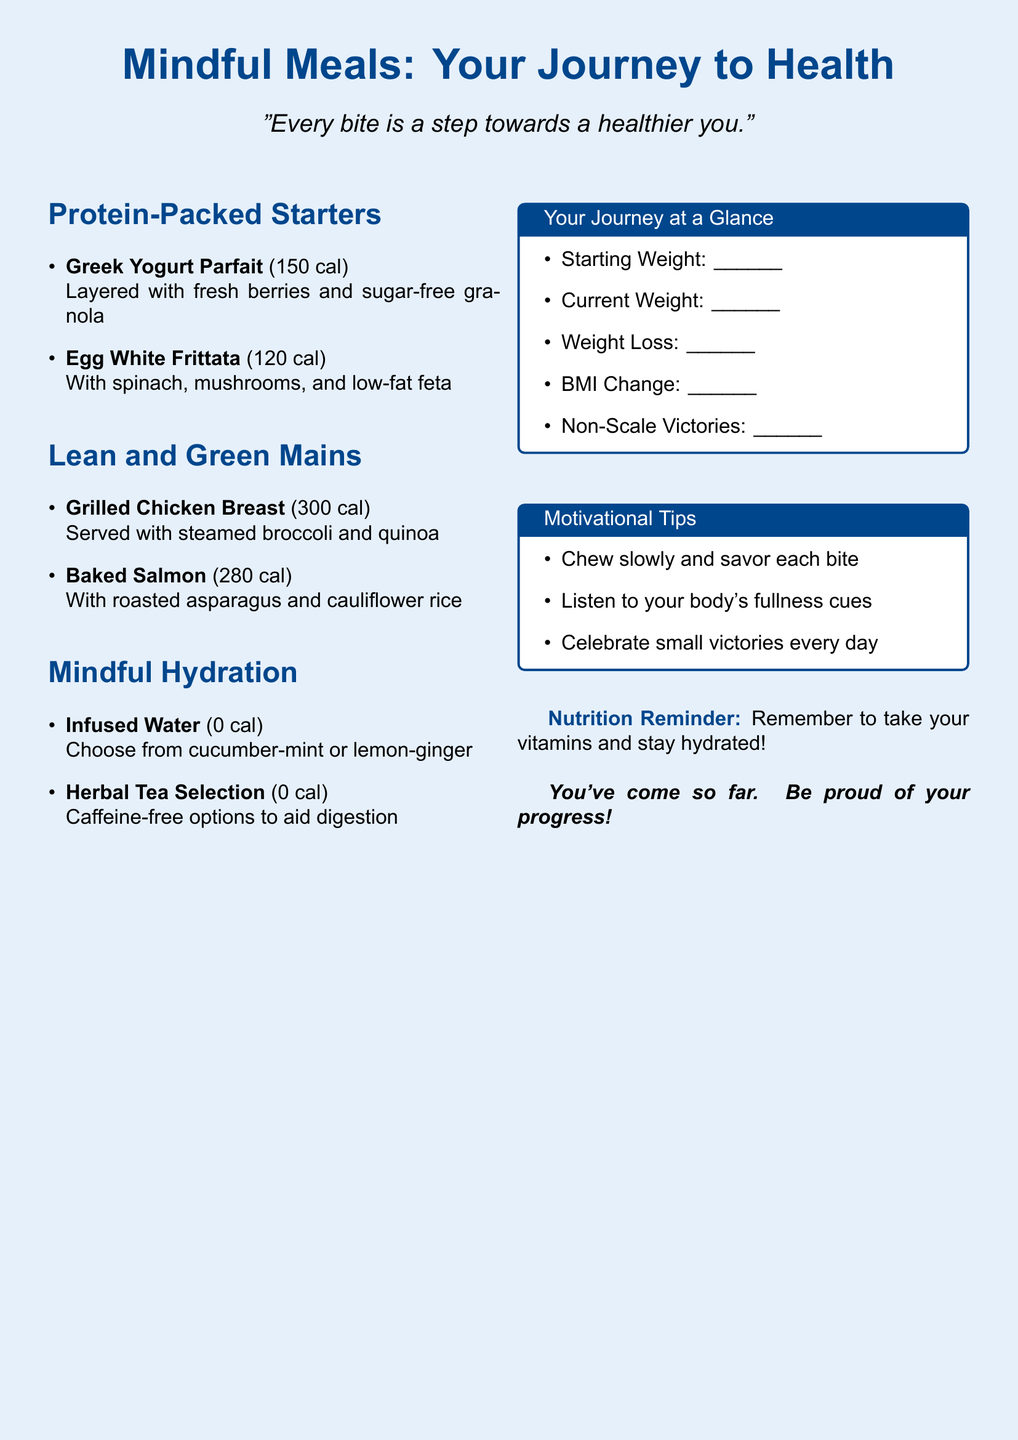what is the title of the menu? The title of the menu is prominently displayed at the top of the document, stating its focus on health and mindful meals.
Answer: Mindful Meals: Your Journey to Health how many calories are in the Greek Yogurt Parfait? The calorie information for the Greek Yogurt Parfait is provided alongside the dish description in the starters section.
Answer: 150 cal what type of tea is included in the Mindful Hydration section? The Mindful Hydration section lists two hydration options, one of which is herbal tea.
Answer: Herbal Tea Selection what is the weight change tracking item mentioned on the journey at a glance section? The journey tracking section includes several items for recording weight progress, one of which specifies weight loss progress.
Answer: Weight Loss list one motivational tip provided in the menu. The menu includes tips to enhance the dining experience and encourage positive eating habits.
Answer: Chew slowly and savor each bite 